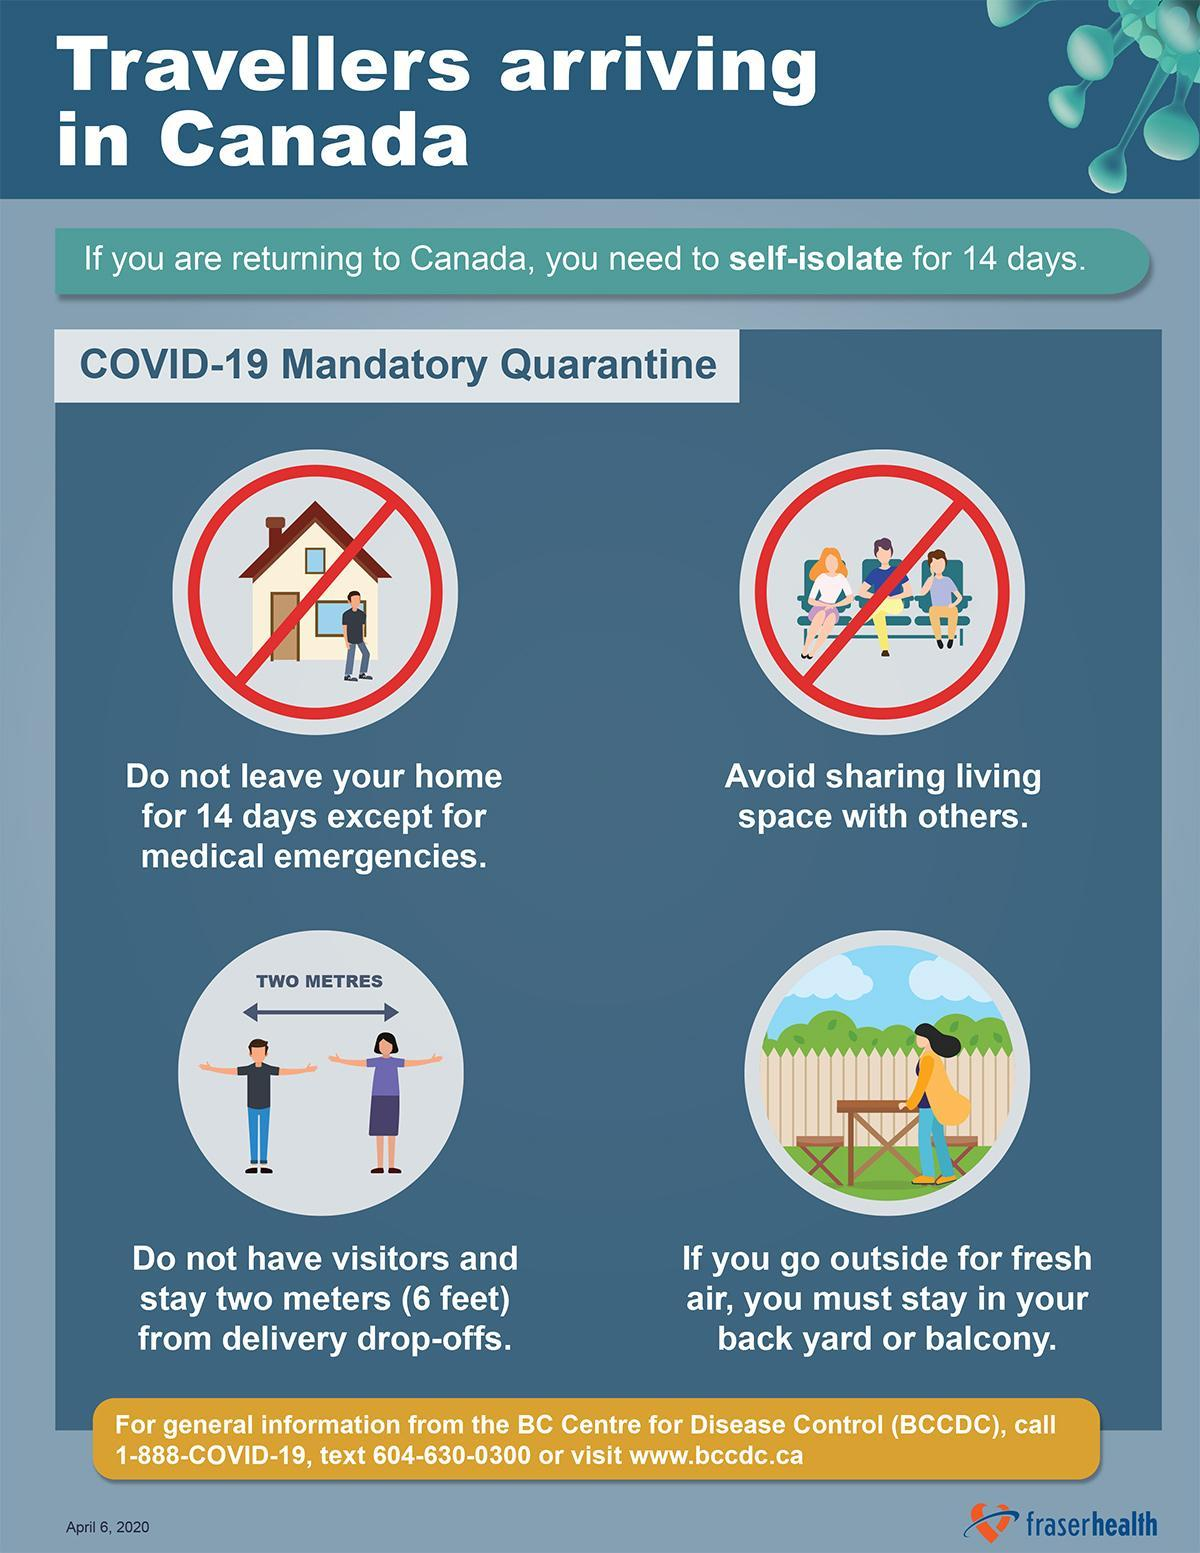How many do's are mentioned in this infographic image?
Answer the question with a short phrase. 2 How many don'ts are mentioned  in this infographic image? 2 